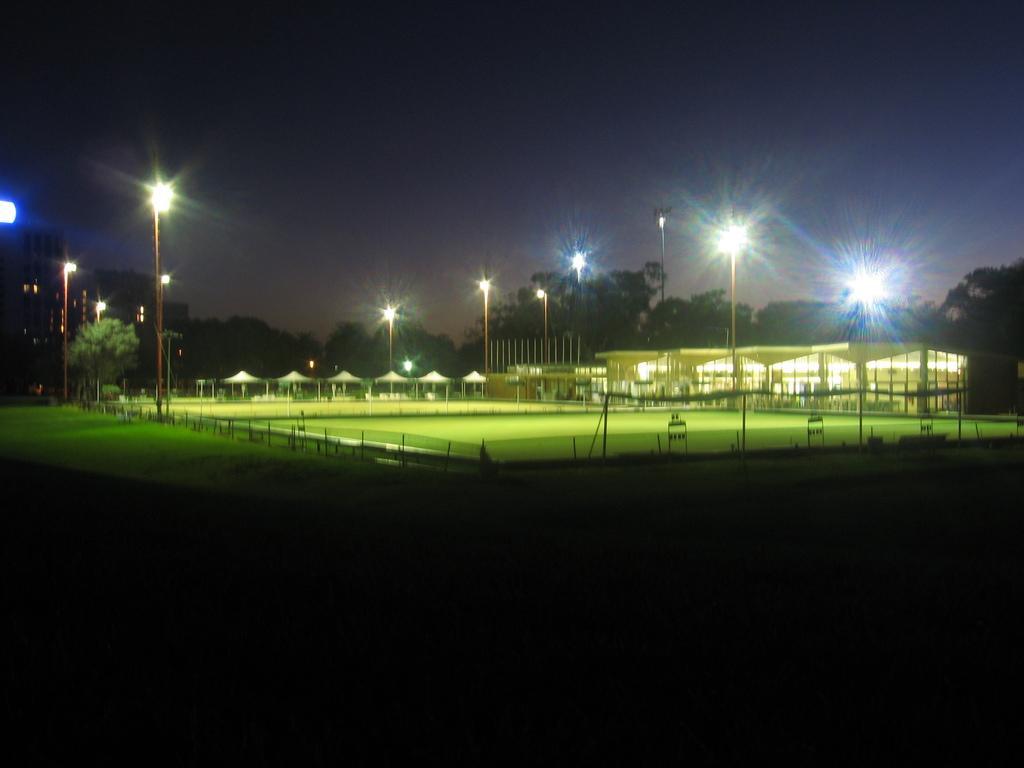Describe this image in one or two sentences. In this image there are buildings and there are tents. We can see poles and lights. In the background there are trees and sky. 